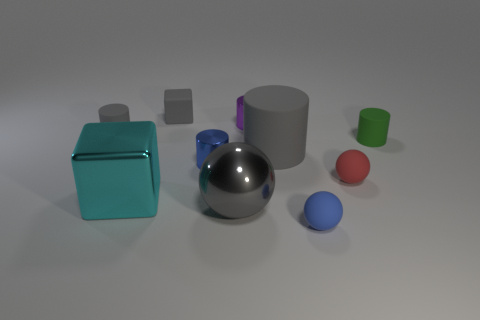There is a blue object to the right of the large ball; is its shape the same as the tiny blue object that is behind the large gray metallic ball?
Offer a very short reply. No. Are there an equal number of blue matte spheres in front of the rubber cube and small blue spheres?
Offer a very short reply. Yes. There is a matte thing left of the gray cube; is there a big rubber cylinder that is behind it?
Your answer should be very brief. No. Is there any other thing that is the same color as the small block?
Give a very brief answer. Yes. Are the tiny thing to the left of the tiny gray rubber cube and the blue cylinder made of the same material?
Make the answer very short. No. Is the number of big spheres that are behind the green cylinder the same as the number of large cyan things on the right side of the tiny gray matte block?
Ensure brevity in your answer.  Yes. There is a gray matte cylinder that is right of the shiny thing behind the green rubber thing; how big is it?
Make the answer very short. Large. There is a sphere that is both to the right of the large gray matte cylinder and behind the small blue matte sphere; what material is it?
Ensure brevity in your answer.  Rubber. What number of other things are there of the same size as the purple shiny thing?
Ensure brevity in your answer.  6. The rubber cube is what color?
Your answer should be very brief. Gray. 